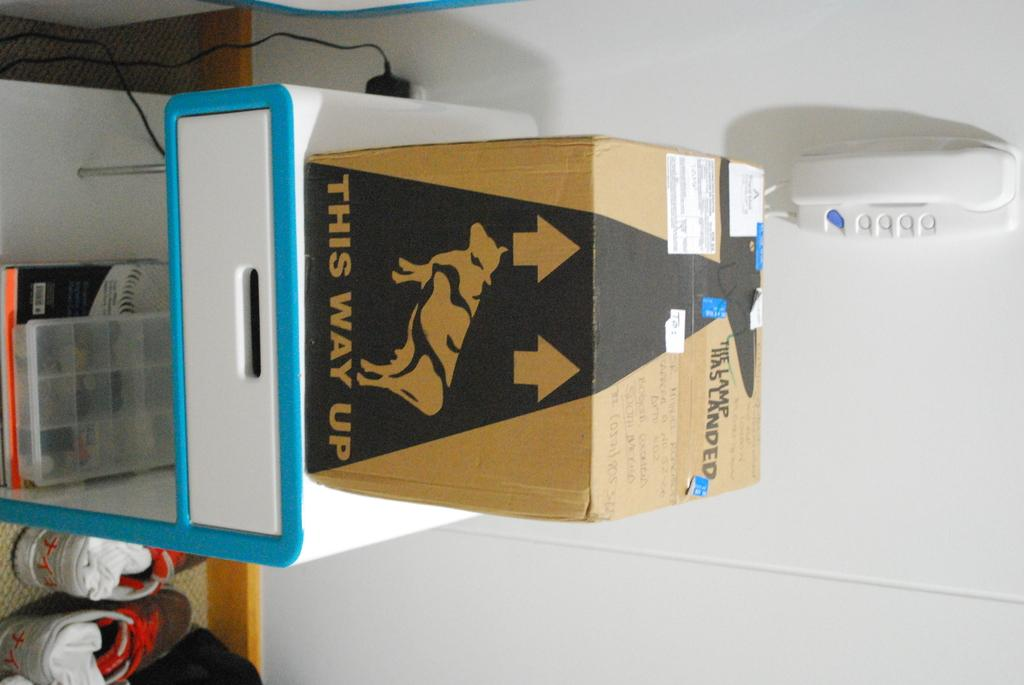<image>
Summarize the visual content of the image. A cardboard box has an arrow and text of "this way up." 